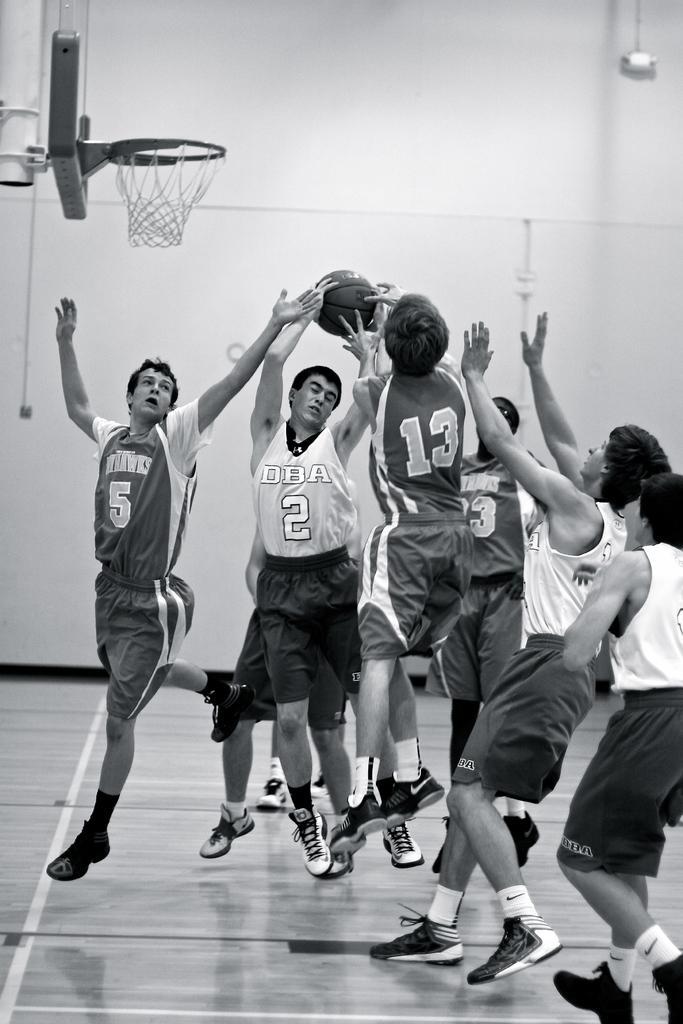Describe this image in one or two sentences. This is a black and white image and here we can see people playing on the floor and in the background, there is a hoop and we can see a ball, rope and an object on the wall. 